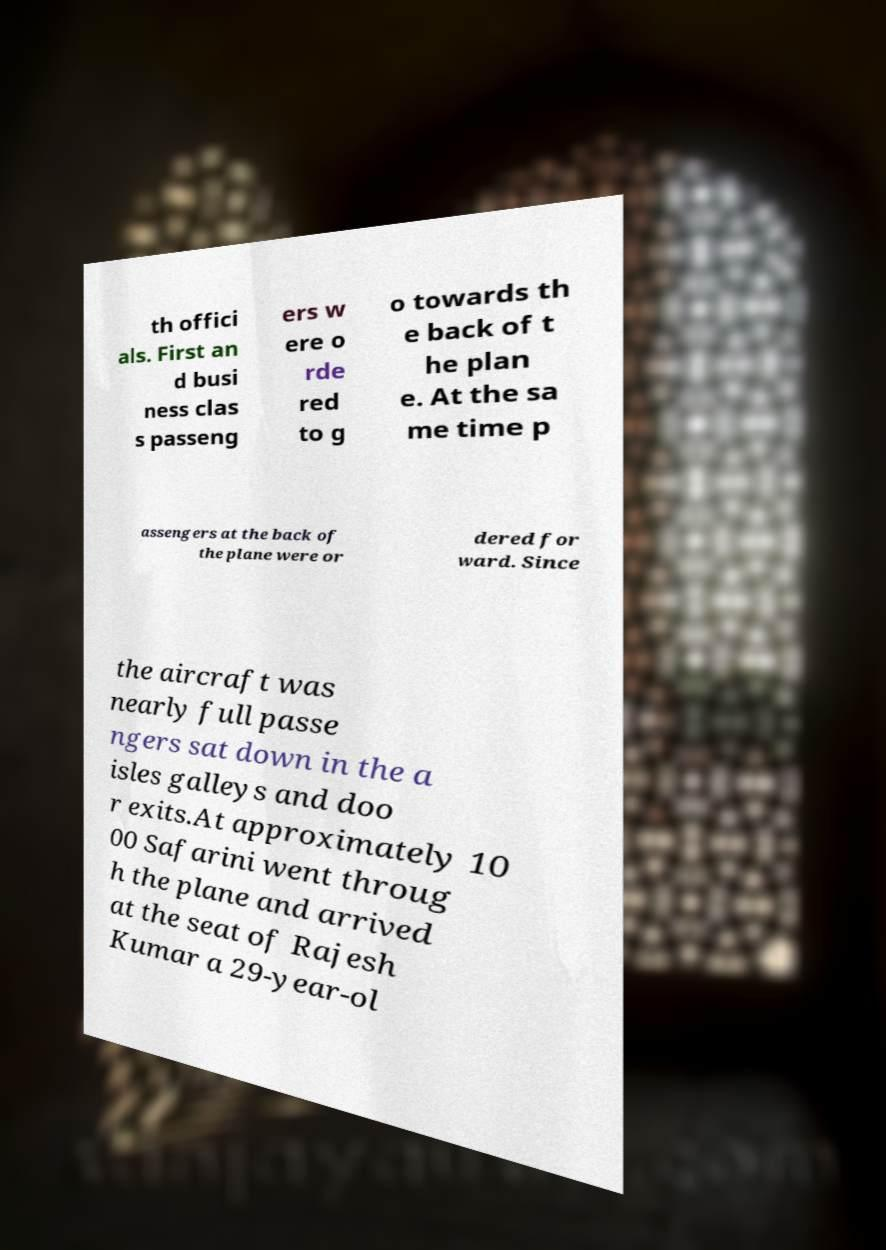Please identify and transcribe the text found in this image. th offici als. First an d busi ness clas s passeng ers w ere o rde red to g o towards th e back of t he plan e. At the sa me time p assengers at the back of the plane were or dered for ward. Since the aircraft was nearly full passe ngers sat down in the a isles galleys and doo r exits.At approximately 10 00 Safarini went throug h the plane and arrived at the seat of Rajesh Kumar a 29-year-ol 